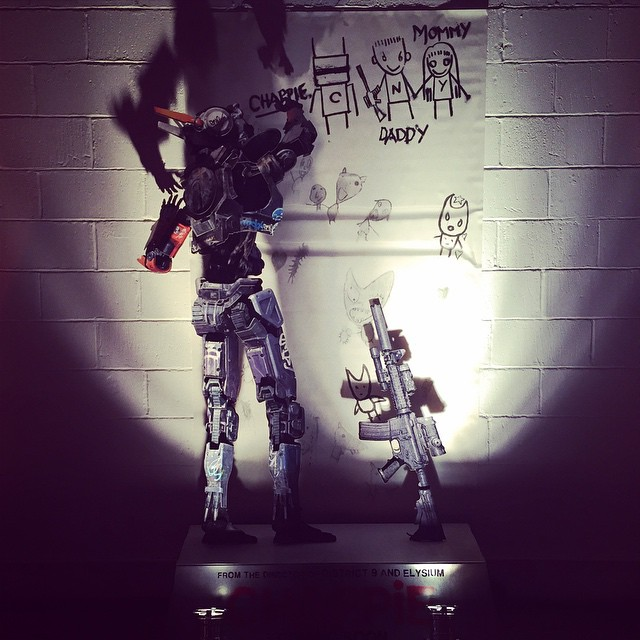How might the child-like drawings impact the robot's perception of its purpose? The child-like drawings could significantly impact the robot's perception of its purpose by instilling a sense of empathy and connection to the human elements in its environment. Seeing these drawings might lead the robot to understand its role not only as a protector and helper but also as a companion in the children's imaginative world. This could influence the robot’s actions and decisions, making it more attentive and responsive to the emotional needs and creative expressions of the children, thereby enhancing its integration into the family dynamics. 